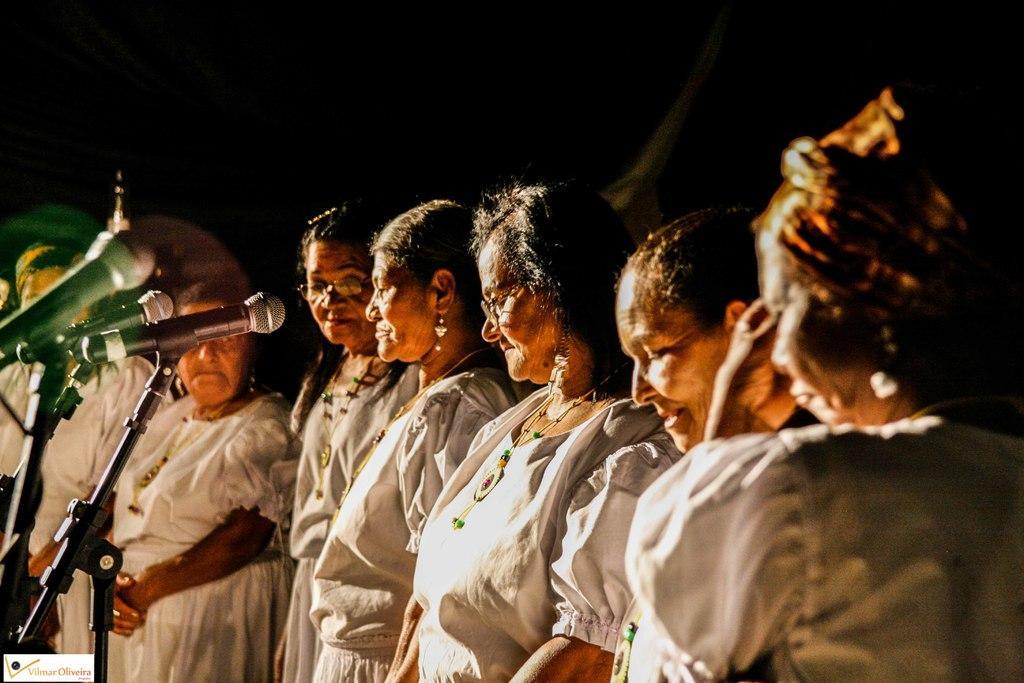Describe this image in one or two sentences. In this picture there is a group of old ladies wearing white dress are singing in the microphone. Behind there is a black background. 